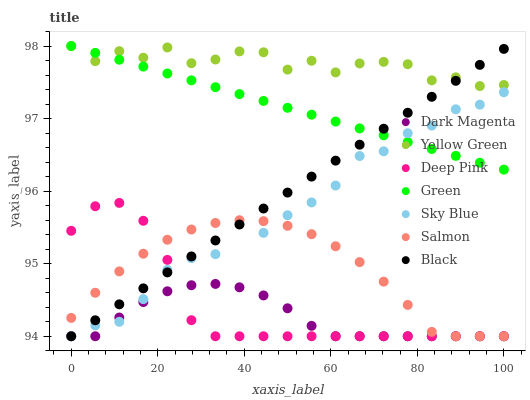Does Dark Magenta have the minimum area under the curve?
Answer yes or no. Yes. Does Yellow Green have the maximum area under the curve?
Answer yes or no. Yes. Does Salmon have the minimum area under the curve?
Answer yes or no. No. Does Salmon have the maximum area under the curve?
Answer yes or no. No. Is Green the smoothest?
Answer yes or no. Yes. Is Yellow Green the roughest?
Answer yes or no. Yes. Is Dark Magenta the smoothest?
Answer yes or no. No. Is Dark Magenta the roughest?
Answer yes or no. No. Does Deep Pink have the lowest value?
Answer yes or no. Yes. Does Green have the lowest value?
Answer yes or no. No. Does Yellow Green have the highest value?
Answer yes or no. Yes. Does Salmon have the highest value?
Answer yes or no. No. Is Deep Pink less than Green?
Answer yes or no. Yes. Is Yellow Green greater than Deep Pink?
Answer yes or no. Yes. Does Sky Blue intersect Deep Pink?
Answer yes or no. Yes. Is Sky Blue less than Deep Pink?
Answer yes or no. No. Is Sky Blue greater than Deep Pink?
Answer yes or no. No. Does Deep Pink intersect Green?
Answer yes or no. No. 